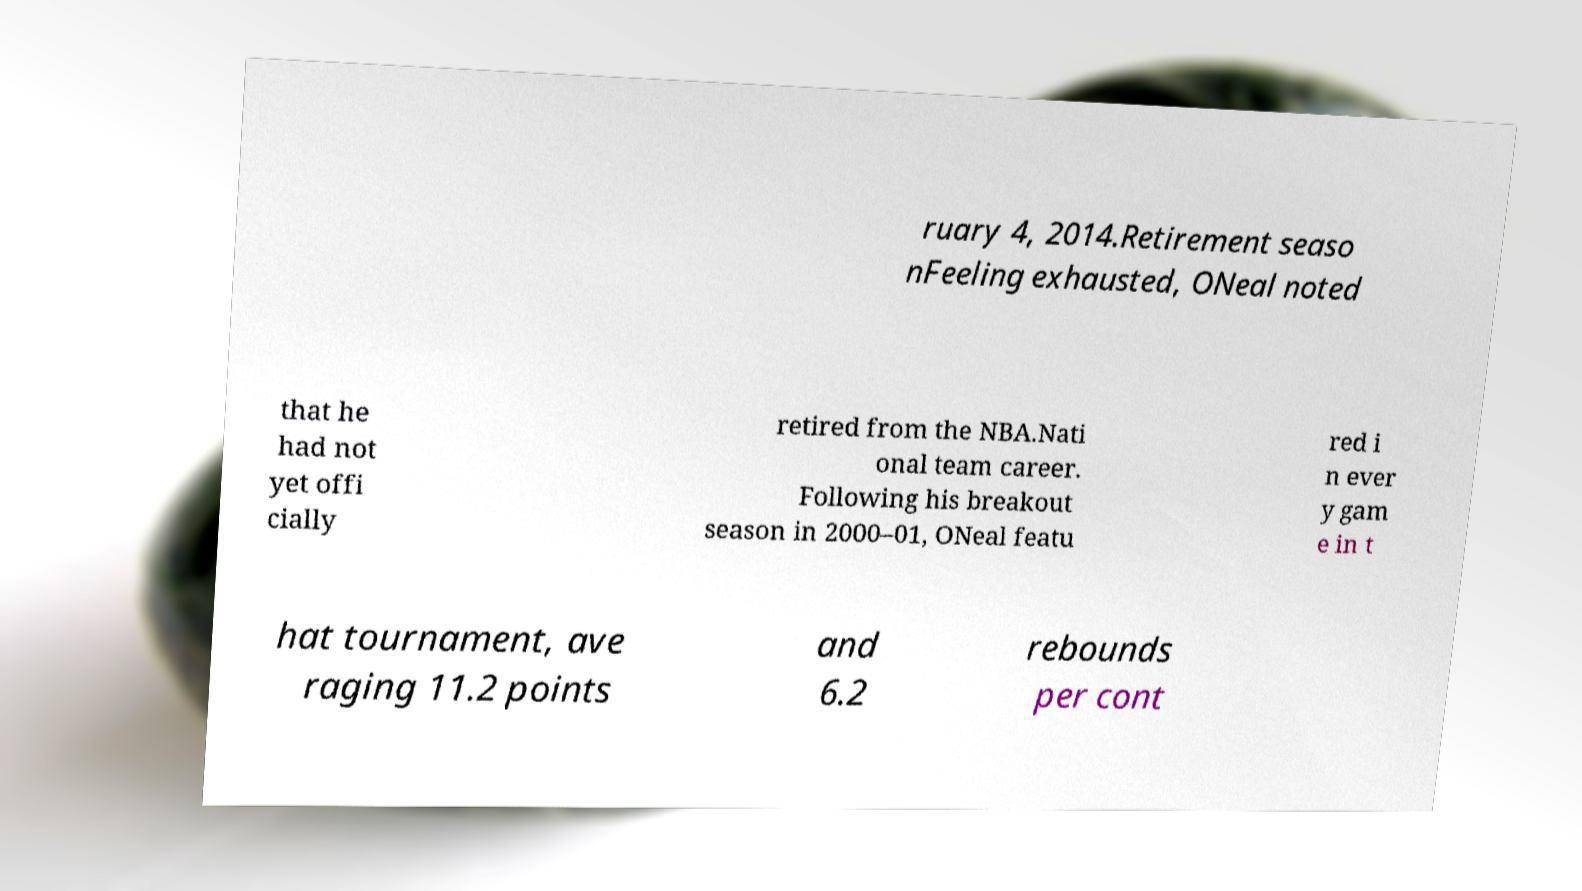Can you read and provide the text displayed in the image?This photo seems to have some interesting text. Can you extract and type it out for me? ruary 4, 2014.Retirement seaso nFeeling exhausted, ONeal noted that he had not yet offi cially retired from the NBA.Nati onal team career. Following his breakout season in 2000–01, ONeal featu red i n ever y gam e in t hat tournament, ave raging 11.2 points and 6.2 rebounds per cont 